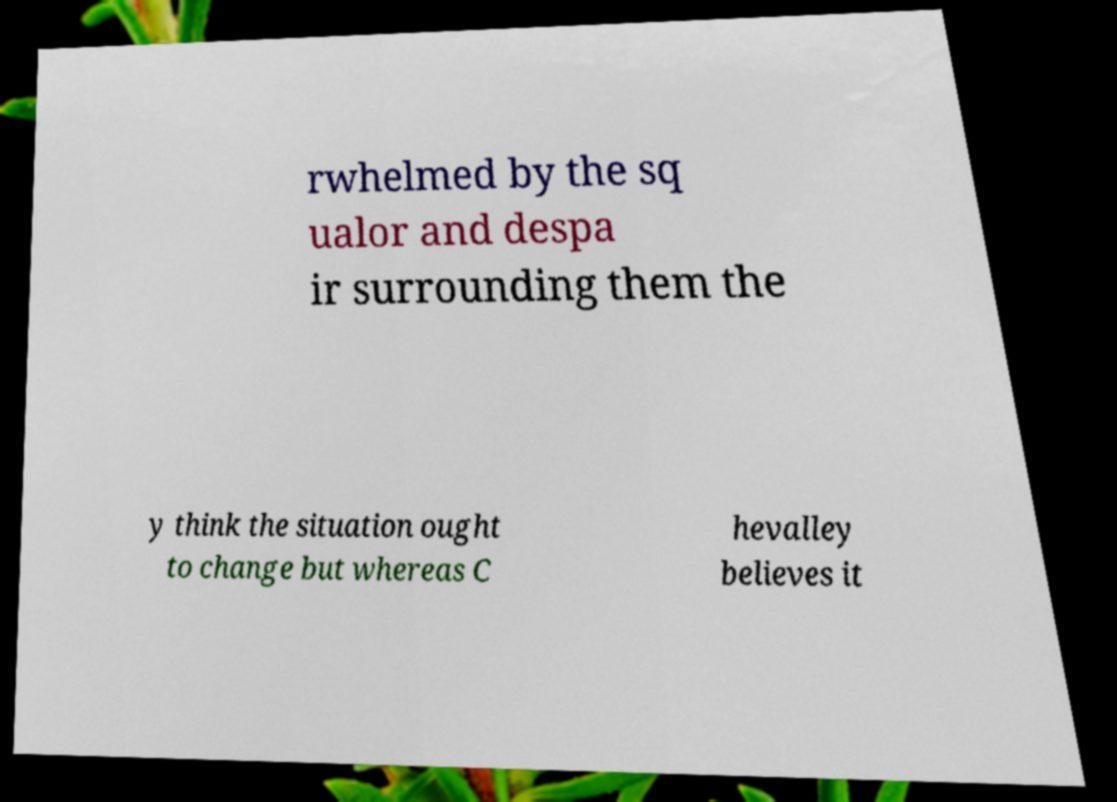Please read and relay the text visible in this image. What does it say? rwhelmed by the sq ualor and despa ir surrounding them the y think the situation ought to change but whereas C hevalley believes it 